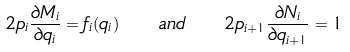<formula> <loc_0><loc_0><loc_500><loc_500>2 p _ { i } \frac { \partial M _ { i } } { \partial q _ { i } } = f _ { i } ( q _ { i } ) \quad a n d \quad 2 p _ { i + 1 } \frac { \partial N _ { i } } { \partial q _ { i + 1 } } = 1</formula> 